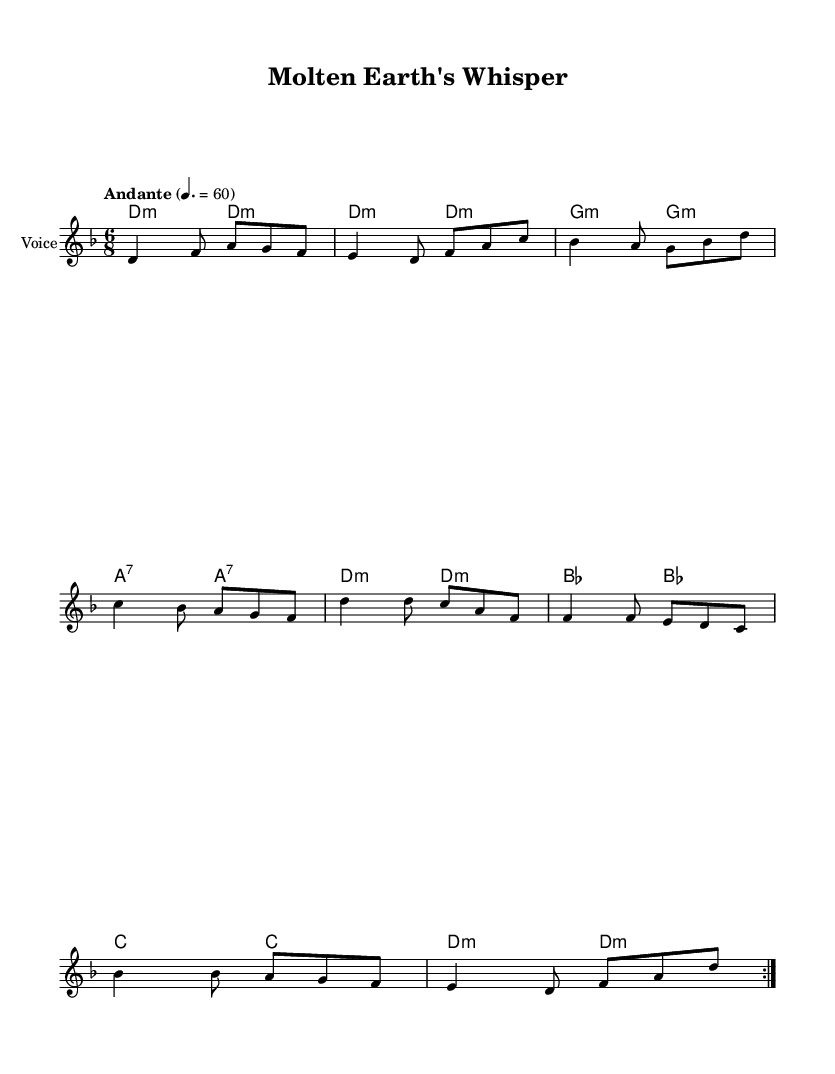What is the key signature of this music? The key signature is D minor, which typically has one flat (B flat) indicated at the beginning of the staff.
Answer: D minor What is the time signature of this music? The time signature is indicated at the beginning and is shown as 6/8, meaning there are six eighth notes per measure.
Answer: 6/8 What is the tempo marking of this piece? The tempo marking is "Andante," which indicates a moderately slow tempo. The specific beat per minute is also provided as 60.
Answer: Andante How many times is the main musical section repeated? The score explicitly shows a repeat sign, indicating that the main section is played twice.
Answer: 2 What type of song structure is used in this piece? The song structure is typical of folk music, featuring verses with lyrics and a repetitive chord progression, specifically resembling a strophic form.
Answer: Verse What is the theme conveyed through the lyrics of this piece? The lyrics focus on environmental conservation and the importance of preserving the geothermal wonders of the Earth, showcasing a nature-centric theme.
Answer: Conservation Which instrument is indicated as the primary vocal performance? The score lists the instrument name as "Voice" above the staff, indicating that the primary performance is for vocals.
Answer: Voice 